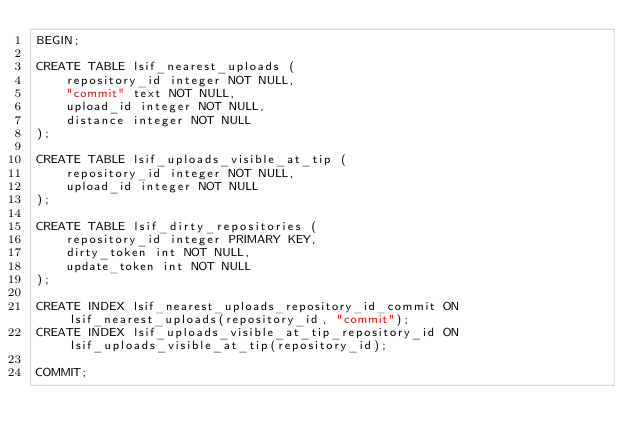Convert code to text. <code><loc_0><loc_0><loc_500><loc_500><_SQL_>BEGIN;

CREATE TABLE lsif_nearest_uploads (
    repository_id integer NOT NULL,
    "commit" text NOT NULL,
    upload_id integer NOT NULL,
    distance integer NOT NULL
);

CREATE TABLE lsif_uploads_visible_at_tip (
    repository_id integer NOT NULL,
    upload_id integer NOT NULL
);

CREATE TABLE lsif_dirty_repositories (
    repository_id integer PRIMARY KEY,
    dirty_token int NOT NULL,
    update_token int NOT NULL
);

CREATE INDEX lsif_nearest_uploads_repository_id_commit ON lsif_nearest_uploads(repository_id, "commit");
CREATE INDEX lsif_uploads_visible_at_tip_repository_id ON lsif_uploads_visible_at_tip(repository_id);

COMMIT;
</code> 